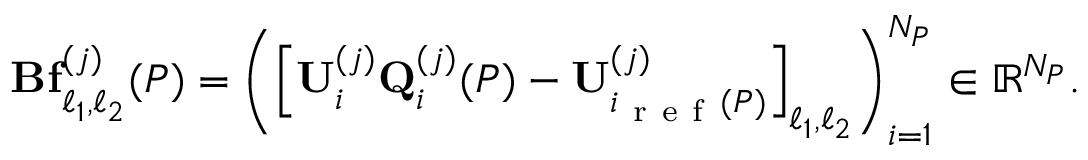Convert formula to latex. <formula><loc_0><loc_0><loc_500><loc_500>B f _ { \ell _ { 1 } , \ell _ { 2 } } ^ { ( j ) } ( P ) = \left ( \left [ U _ { i } ^ { ( j ) } Q _ { i } ^ { ( j ) } ( P ) - U _ { i _ { r e f } ( P ) } ^ { ( j ) } \right ] _ { \ell _ { 1 } , \ell _ { 2 } } \right ) _ { i = 1 } ^ { N _ { P } } \in \mathbb { R } ^ { N _ { P } } .</formula> 